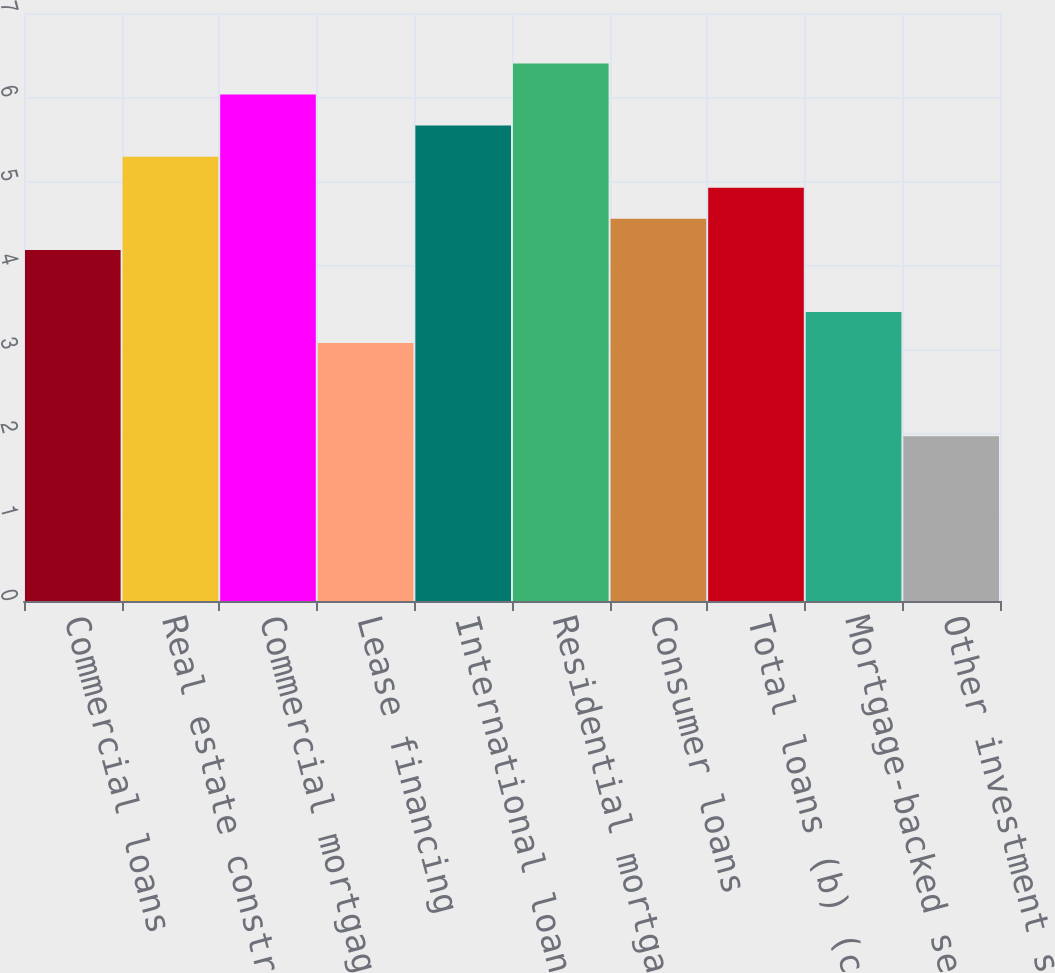Convert chart to OTSL. <chart><loc_0><loc_0><loc_500><loc_500><bar_chart><fcel>Commercial loans<fcel>Real estate construction loans<fcel>Commercial mortgage loans<fcel>Lease financing<fcel>International loans<fcel>Residential mortgage loans<fcel>Consumer loans<fcel>Total loans (b) (c)<fcel>Mortgage-backed securities<fcel>Other investment securities<nl><fcel>4.18<fcel>5.29<fcel>6.03<fcel>3.07<fcel>5.66<fcel>6.4<fcel>4.55<fcel>4.92<fcel>3.44<fcel>1.96<nl></chart> 